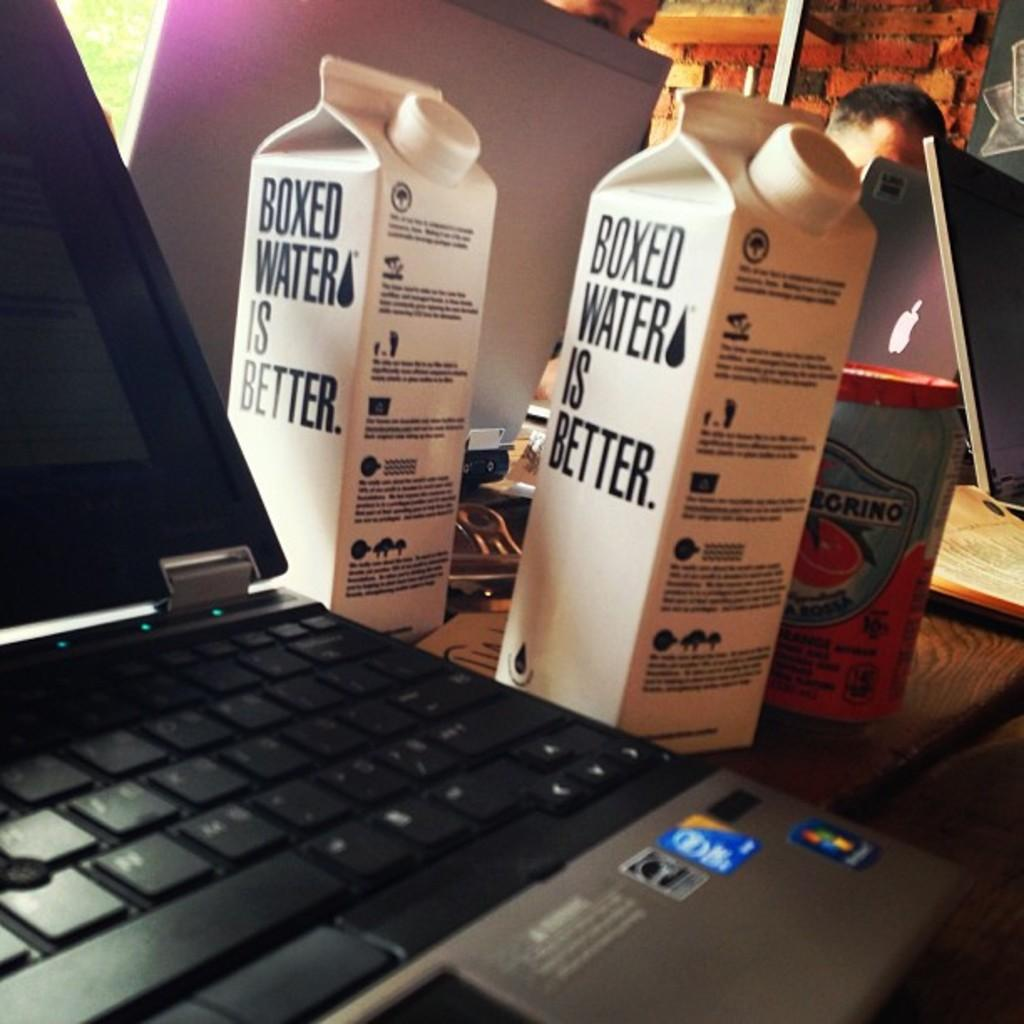<image>
Render a clear and concise summary of the photo. A computer has two cartons next to it that say boxed water is better on the side. 